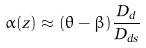<formula> <loc_0><loc_0><loc_500><loc_500>\alpha ( z ) \approx ( \theta - \beta ) \frac { D _ { d } } { D _ { d s } }</formula> 